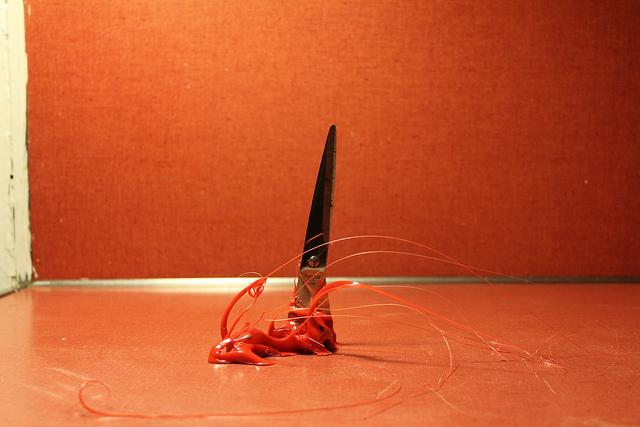What color is the wall?
Write a very short answer. Orange. What did this used to be?
Give a very brief answer. Scissors. Is this outside?
Short answer required. No. 